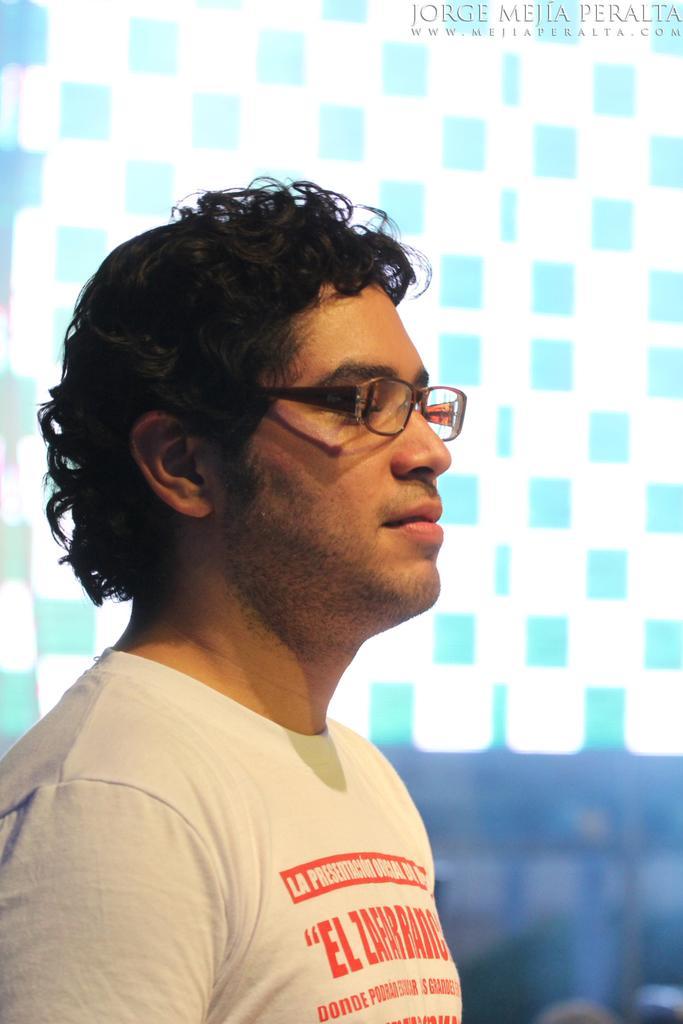Please provide a concise description of this image. In the image we can see there is a person standing and he is wearing spectacles and t-shirt. 